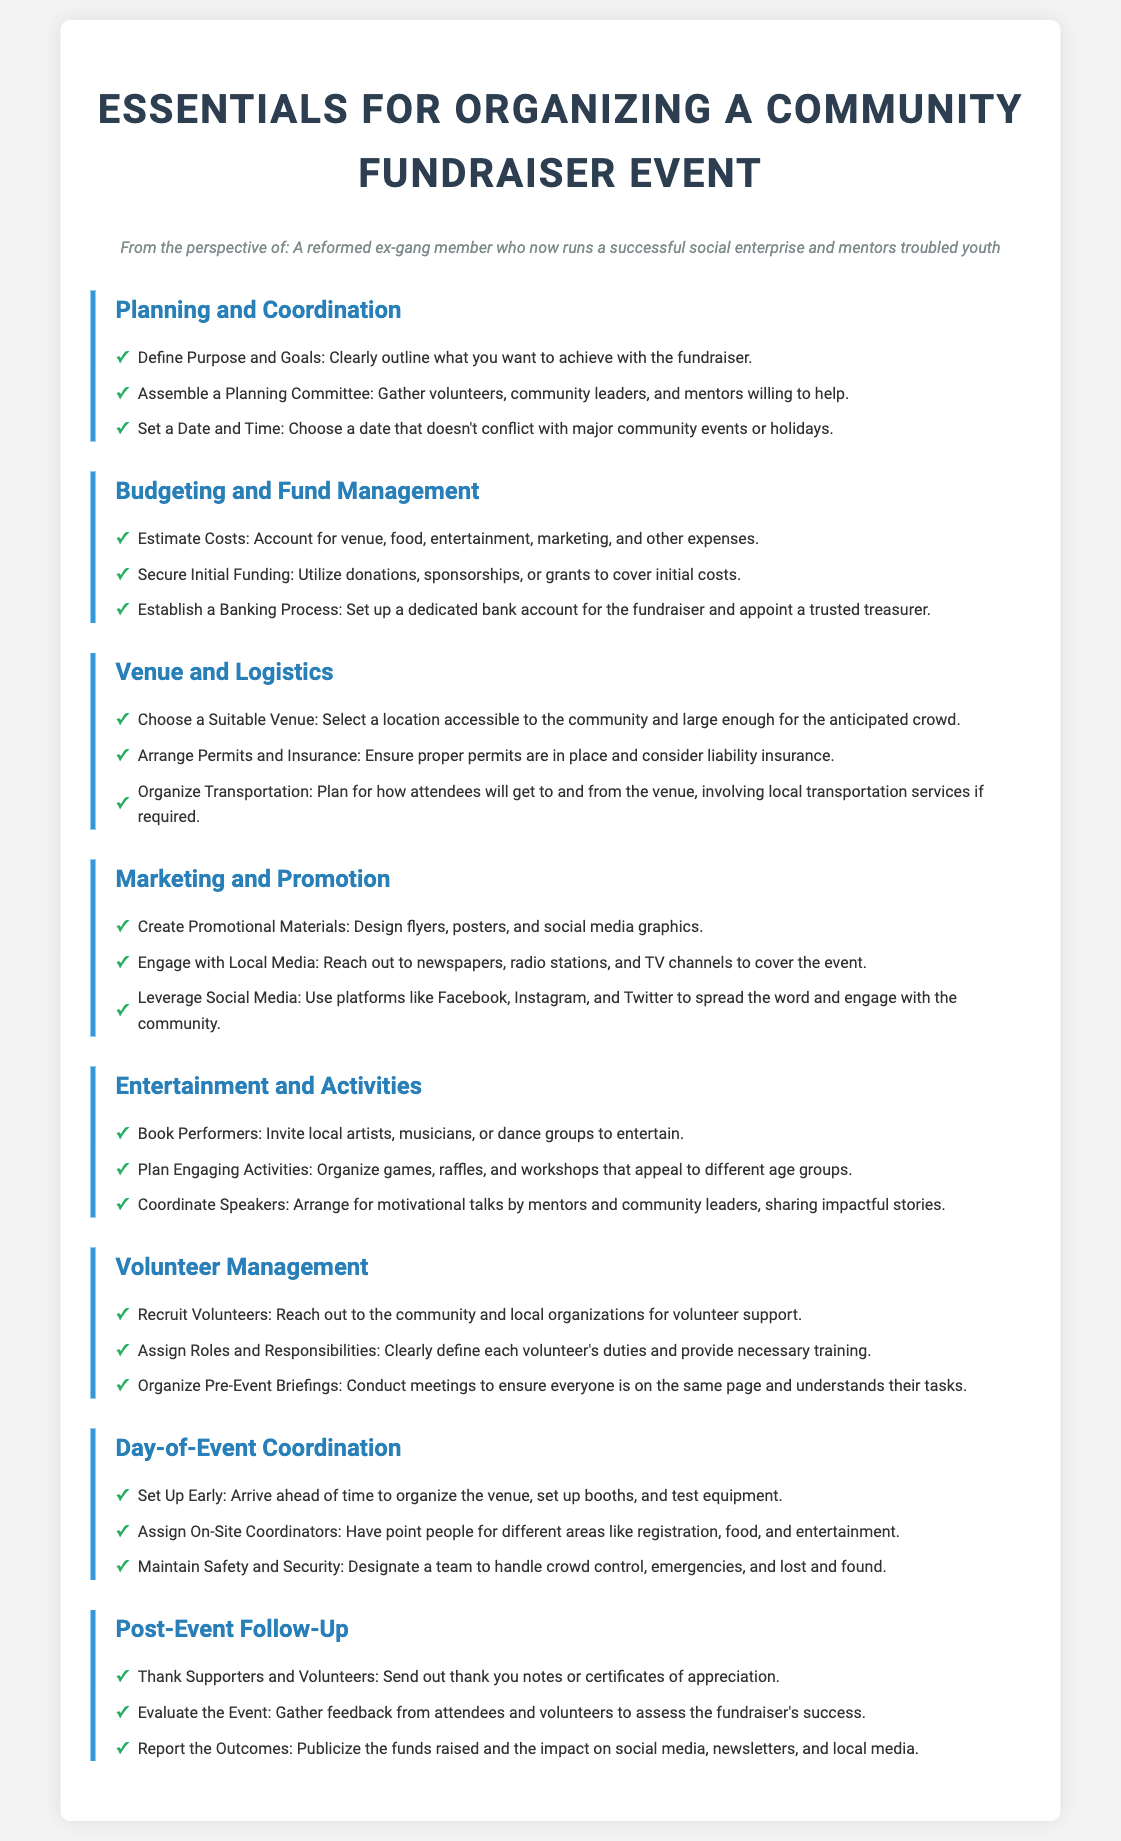what is the title of the document? The title is stated prominently at the top of the document, introducing the main topic.
Answer: Essentials for Organizing a Community Fundraiser Event who should be on the planning committee? The document suggests involving volunteers, community leaders, and mentors in the planning committee.
Answer: Volunteers, community leaders, and mentors how many sections are in the checklist? The document outlines multiple sections that each deal with different aspects of organizing a fundraiser.
Answer: Eight what is one way to engage with local media? The document describes reaching out to various media outlets to cover the event as a method for engagement.
Answer: Reach out to newspapers, radio stations, and TV channels what is a recommended post-event action? The document mentions thanking supporters and volunteers as a crucial follow-up after the event.
Answer: Thank supporters and volunteers what should you establish for managing funds? The document highlights the need to set up a dedicated bank account and appoint a trusted treasurer.
Answer: A dedicated bank account how should volunteers be prepared for the event? The document indicates that assigning roles and conducting pre-event briefings are important for volunteer preparation.
Answer: Assign roles and conduct pre-event briefings what is required to ensure safety at the event? The document specifies the need to designate a team for crowd control and emergencies for safety.
Answer: Designate a team who could be invited to perform at the fundraiser? Local artists, musicians, or dance groups could entertain at the event, as stated in the document.
Answer: Local artists, musicians, or dance groups 